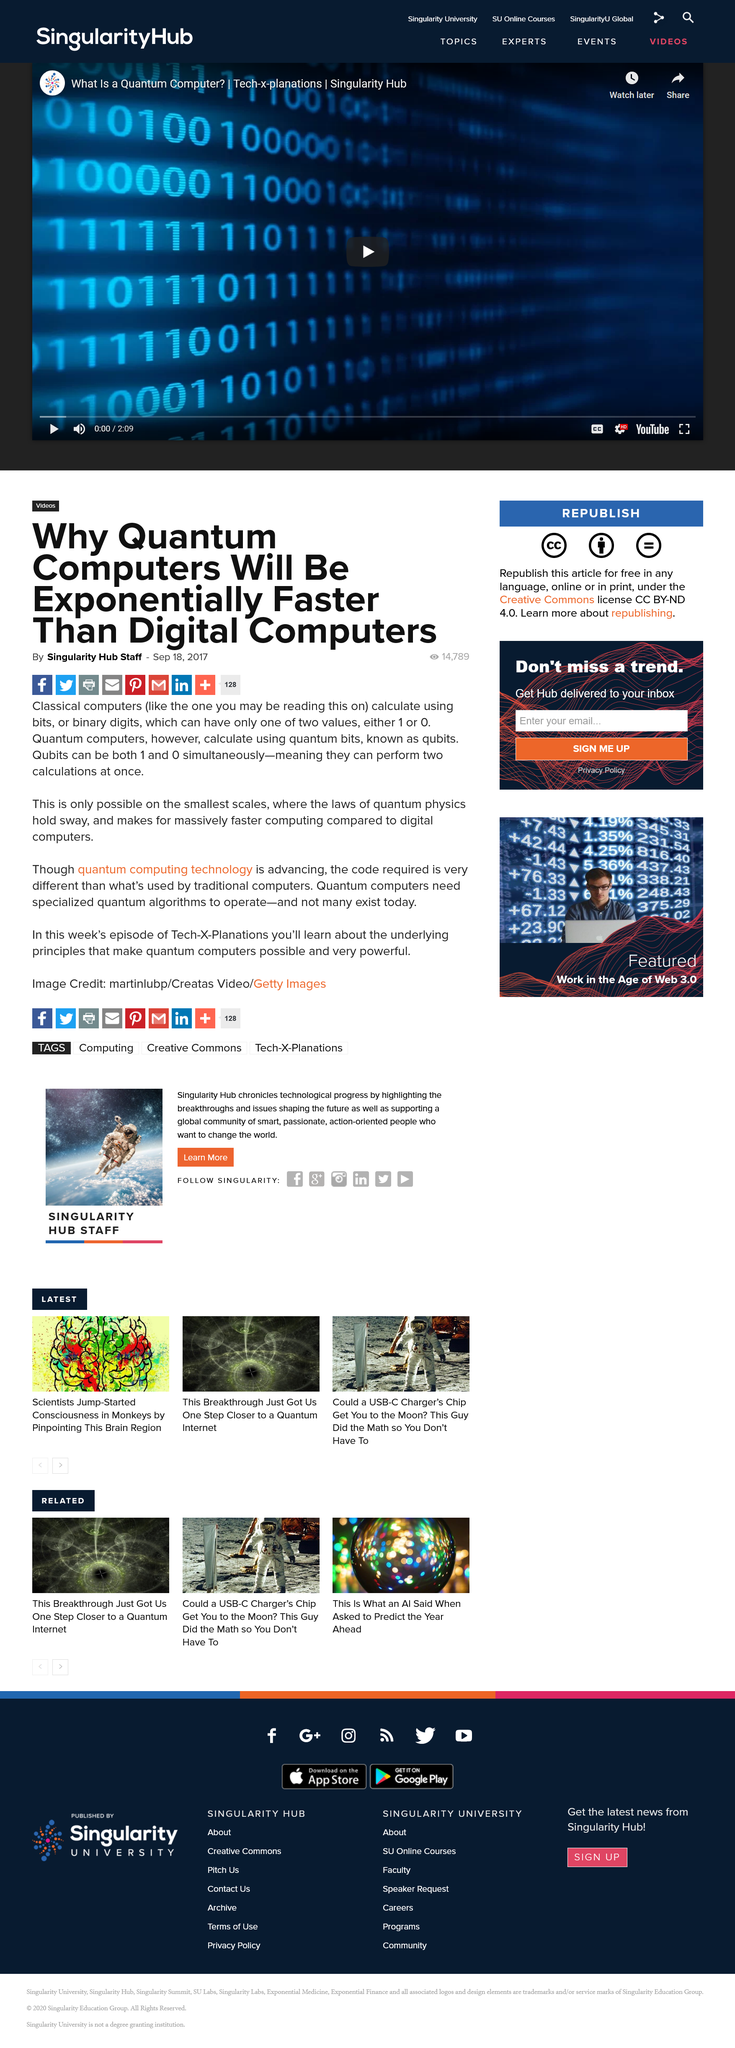Identify some key points in this picture. The laws of physics hold sway on the smallest scales. Classical computers use bits, or binary digits, to calculate. Quantum computers use qubits, a type of quantum bit, to perform calculations. 